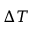Convert formula to latex. <formula><loc_0><loc_0><loc_500><loc_500>\Delta T</formula> 